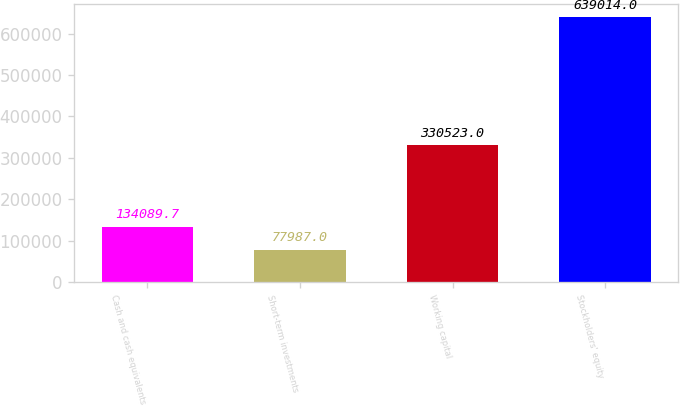Convert chart to OTSL. <chart><loc_0><loc_0><loc_500><loc_500><bar_chart><fcel>Cash and cash equivalents<fcel>Short-term investments<fcel>Working capital<fcel>Stockholders' equity<nl><fcel>134090<fcel>77987<fcel>330523<fcel>639014<nl></chart> 